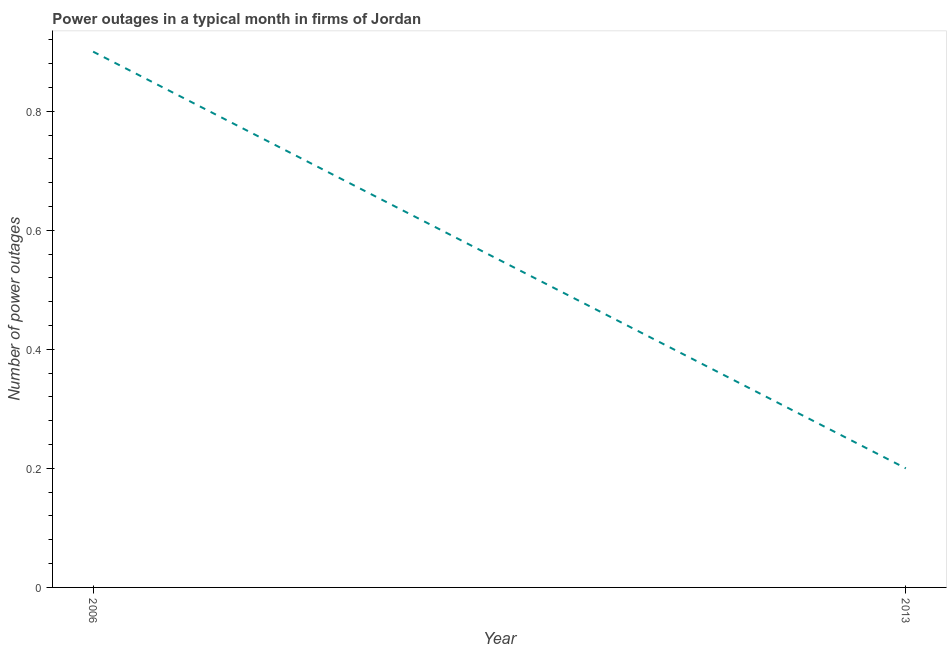In which year was the number of power outages maximum?
Provide a succinct answer. 2006. In which year was the number of power outages minimum?
Offer a very short reply. 2013. What is the sum of the number of power outages?
Your answer should be compact. 1.1. What is the difference between the number of power outages in 2006 and 2013?
Ensure brevity in your answer.  0.7. What is the average number of power outages per year?
Offer a terse response. 0.55. What is the median number of power outages?
Your answer should be very brief. 0.55. What is the ratio of the number of power outages in 2006 to that in 2013?
Offer a terse response. 4.5. In how many years, is the number of power outages greater than the average number of power outages taken over all years?
Offer a terse response. 1. How many lines are there?
Ensure brevity in your answer.  1. How many years are there in the graph?
Offer a terse response. 2. Are the values on the major ticks of Y-axis written in scientific E-notation?
Your response must be concise. No. Does the graph contain grids?
Your answer should be very brief. No. What is the title of the graph?
Keep it short and to the point. Power outages in a typical month in firms of Jordan. What is the label or title of the X-axis?
Give a very brief answer. Year. What is the label or title of the Y-axis?
Ensure brevity in your answer.  Number of power outages. What is the Number of power outages in 2006?
Provide a short and direct response. 0.9. What is the ratio of the Number of power outages in 2006 to that in 2013?
Provide a succinct answer. 4.5. 